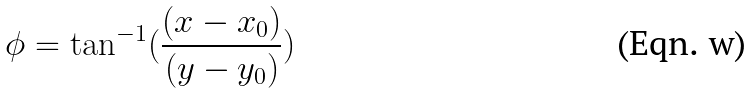Convert formula to latex. <formula><loc_0><loc_0><loc_500><loc_500>\phi = \tan ^ { - 1 } ( \frac { ( x - x _ { 0 } ) } { ( y - y _ { 0 } ) } )</formula> 